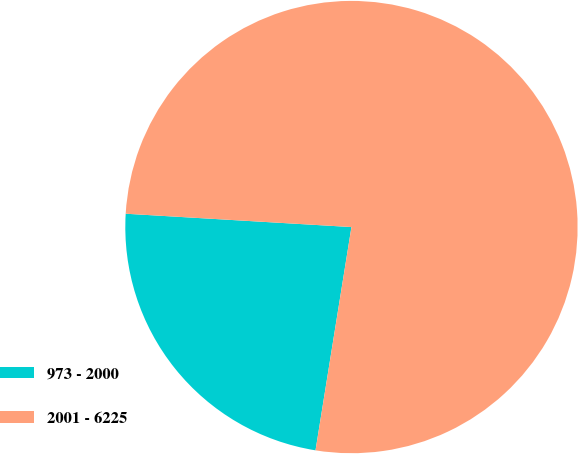Convert chart to OTSL. <chart><loc_0><loc_0><loc_500><loc_500><pie_chart><fcel>973 - 2000<fcel>2001 - 6225<nl><fcel>23.4%<fcel>76.6%<nl></chart> 